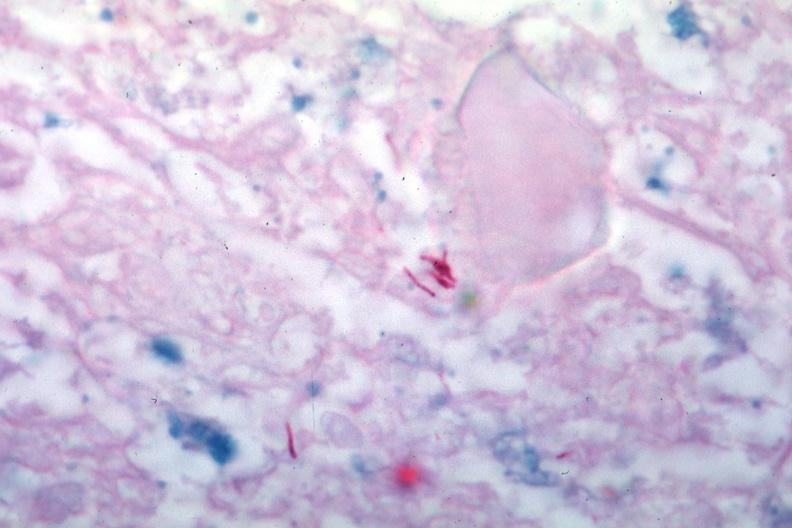s tuberculosis present?
Answer the question using a single word or phrase. Yes 